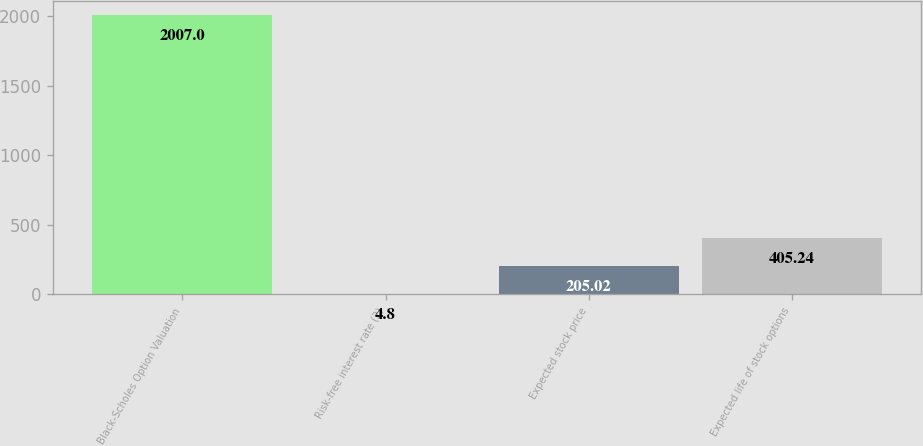Convert chart. <chart><loc_0><loc_0><loc_500><loc_500><bar_chart><fcel>Black-Scholes Option Valuation<fcel>Risk-free interest rate (2)<fcel>Expected stock price<fcel>Expected life of stock options<nl><fcel>2007<fcel>4.8<fcel>205.02<fcel>405.24<nl></chart> 